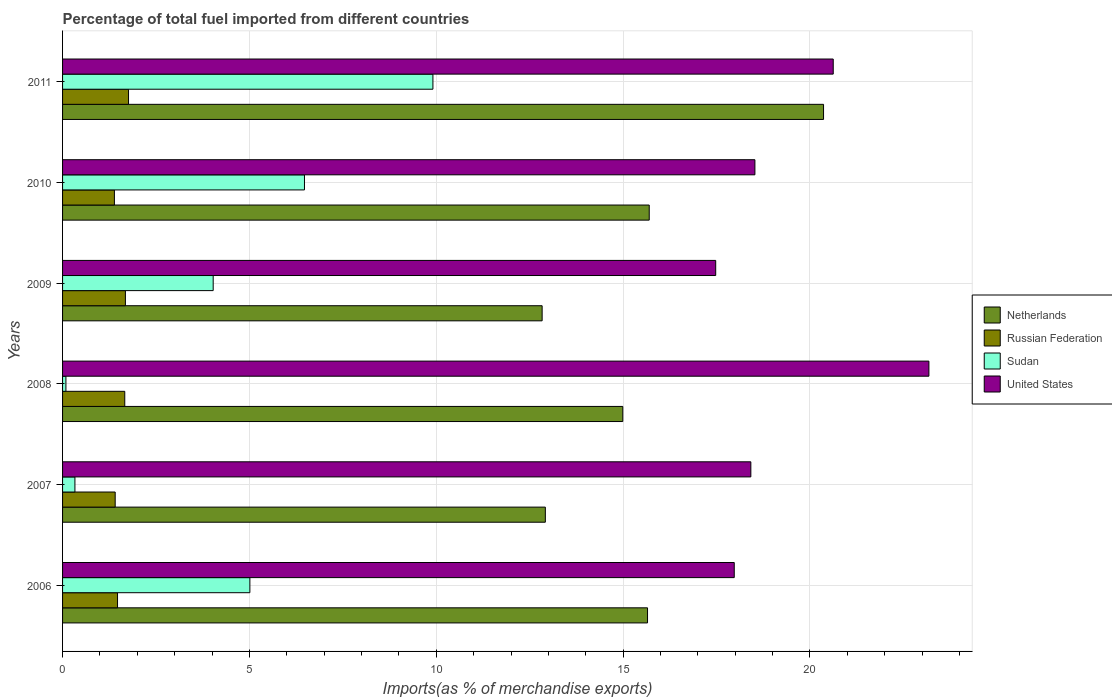How many groups of bars are there?
Make the answer very short. 6. Are the number of bars per tick equal to the number of legend labels?
Your response must be concise. Yes. How many bars are there on the 4th tick from the bottom?
Offer a very short reply. 4. What is the percentage of imports to different countries in Sudan in 2008?
Give a very brief answer. 0.09. Across all years, what is the maximum percentage of imports to different countries in Sudan?
Your response must be concise. 9.91. Across all years, what is the minimum percentage of imports to different countries in Netherlands?
Offer a terse response. 12.83. In which year was the percentage of imports to different countries in United States minimum?
Ensure brevity in your answer.  2009. What is the total percentage of imports to different countries in United States in the graph?
Your answer should be compact. 116.2. What is the difference between the percentage of imports to different countries in Sudan in 2008 and that in 2010?
Your answer should be compact. -6.38. What is the difference between the percentage of imports to different countries in Russian Federation in 2009 and the percentage of imports to different countries in United States in 2011?
Your response must be concise. -18.94. What is the average percentage of imports to different countries in United States per year?
Your answer should be very brief. 19.37. In the year 2011, what is the difference between the percentage of imports to different countries in Netherlands and percentage of imports to different countries in United States?
Give a very brief answer. -0.26. In how many years, is the percentage of imports to different countries in United States greater than 12 %?
Your answer should be very brief. 6. What is the ratio of the percentage of imports to different countries in Russian Federation in 2009 to that in 2010?
Your response must be concise. 1.21. Is the difference between the percentage of imports to different countries in Netherlands in 2008 and 2011 greater than the difference between the percentage of imports to different countries in United States in 2008 and 2011?
Your answer should be compact. No. What is the difference between the highest and the second highest percentage of imports to different countries in Netherlands?
Your response must be concise. 4.66. What is the difference between the highest and the lowest percentage of imports to different countries in Netherlands?
Your answer should be compact. 7.53. Is the sum of the percentage of imports to different countries in Netherlands in 2008 and 2011 greater than the maximum percentage of imports to different countries in Russian Federation across all years?
Give a very brief answer. Yes. What does the 3rd bar from the top in 2008 represents?
Provide a short and direct response. Russian Federation. What does the 2nd bar from the bottom in 2008 represents?
Your answer should be compact. Russian Federation. Is it the case that in every year, the sum of the percentage of imports to different countries in United States and percentage of imports to different countries in Sudan is greater than the percentage of imports to different countries in Russian Federation?
Ensure brevity in your answer.  Yes. Are the values on the major ticks of X-axis written in scientific E-notation?
Keep it short and to the point. No. Does the graph contain any zero values?
Provide a short and direct response. No. Where does the legend appear in the graph?
Your response must be concise. Center right. What is the title of the graph?
Offer a terse response. Percentage of total fuel imported from different countries. What is the label or title of the X-axis?
Keep it short and to the point. Imports(as % of merchandise exports). What is the Imports(as % of merchandise exports) of Netherlands in 2006?
Your answer should be very brief. 15.65. What is the Imports(as % of merchandise exports) in Russian Federation in 2006?
Offer a terse response. 1.47. What is the Imports(as % of merchandise exports) in Sudan in 2006?
Offer a terse response. 5.01. What is the Imports(as % of merchandise exports) in United States in 2006?
Give a very brief answer. 17.97. What is the Imports(as % of merchandise exports) in Netherlands in 2007?
Offer a very short reply. 12.92. What is the Imports(as % of merchandise exports) in Russian Federation in 2007?
Provide a succinct answer. 1.41. What is the Imports(as % of merchandise exports) in Sudan in 2007?
Give a very brief answer. 0.33. What is the Imports(as % of merchandise exports) of United States in 2007?
Make the answer very short. 18.42. What is the Imports(as % of merchandise exports) in Netherlands in 2008?
Make the answer very short. 14.99. What is the Imports(as % of merchandise exports) of Russian Federation in 2008?
Provide a succinct answer. 1.66. What is the Imports(as % of merchandise exports) in Sudan in 2008?
Offer a terse response. 0.09. What is the Imports(as % of merchandise exports) of United States in 2008?
Your answer should be very brief. 23.18. What is the Imports(as % of merchandise exports) in Netherlands in 2009?
Offer a very short reply. 12.83. What is the Imports(as % of merchandise exports) in Russian Federation in 2009?
Your answer should be very brief. 1.68. What is the Imports(as % of merchandise exports) in Sudan in 2009?
Provide a short and direct response. 4.03. What is the Imports(as % of merchandise exports) of United States in 2009?
Your answer should be very brief. 17.48. What is the Imports(as % of merchandise exports) in Netherlands in 2010?
Give a very brief answer. 15.7. What is the Imports(as % of merchandise exports) in Russian Federation in 2010?
Give a very brief answer. 1.39. What is the Imports(as % of merchandise exports) of Sudan in 2010?
Offer a terse response. 6.47. What is the Imports(as % of merchandise exports) in United States in 2010?
Your answer should be very brief. 18.53. What is the Imports(as % of merchandise exports) in Netherlands in 2011?
Your response must be concise. 20.36. What is the Imports(as % of merchandise exports) of Russian Federation in 2011?
Offer a terse response. 1.77. What is the Imports(as % of merchandise exports) of Sudan in 2011?
Keep it short and to the point. 9.91. What is the Imports(as % of merchandise exports) of United States in 2011?
Your response must be concise. 20.62. Across all years, what is the maximum Imports(as % of merchandise exports) of Netherlands?
Offer a very short reply. 20.36. Across all years, what is the maximum Imports(as % of merchandise exports) in Russian Federation?
Give a very brief answer. 1.77. Across all years, what is the maximum Imports(as % of merchandise exports) in Sudan?
Your answer should be compact. 9.91. Across all years, what is the maximum Imports(as % of merchandise exports) of United States?
Provide a succinct answer. 23.18. Across all years, what is the minimum Imports(as % of merchandise exports) of Netherlands?
Ensure brevity in your answer.  12.83. Across all years, what is the minimum Imports(as % of merchandise exports) of Russian Federation?
Offer a very short reply. 1.39. Across all years, what is the minimum Imports(as % of merchandise exports) of Sudan?
Keep it short and to the point. 0.09. Across all years, what is the minimum Imports(as % of merchandise exports) of United States?
Offer a terse response. 17.48. What is the total Imports(as % of merchandise exports) in Netherlands in the graph?
Keep it short and to the point. 92.46. What is the total Imports(as % of merchandise exports) of Russian Federation in the graph?
Your answer should be compact. 9.38. What is the total Imports(as % of merchandise exports) in Sudan in the graph?
Provide a short and direct response. 25.85. What is the total Imports(as % of merchandise exports) in United States in the graph?
Your answer should be very brief. 116.2. What is the difference between the Imports(as % of merchandise exports) in Netherlands in 2006 and that in 2007?
Your response must be concise. 2.73. What is the difference between the Imports(as % of merchandise exports) in Russian Federation in 2006 and that in 2007?
Make the answer very short. 0.06. What is the difference between the Imports(as % of merchandise exports) of Sudan in 2006 and that in 2007?
Your answer should be compact. 4.68. What is the difference between the Imports(as % of merchandise exports) of United States in 2006 and that in 2007?
Offer a terse response. -0.44. What is the difference between the Imports(as % of merchandise exports) in Netherlands in 2006 and that in 2008?
Give a very brief answer. 0.66. What is the difference between the Imports(as % of merchandise exports) of Russian Federation in 2006 and that in 2008?
Give a very brief answer. -0.19. What is the difference between the Imports(as % of merchandise exports) of Sudan in 2006 and that in 2008?
Give a very brief answer. 4.92. What is the difference between the Imports(as % of merchandise exports) of United States in 2006 and that in 2008?
Ensure brevity in your answer.  -5.21. What is the difference between the Imports(as % of merchandise exports) of Netherlands in 2006 and that in 2009?
Provide a short and direct response. 2.82. What is the difference between the Imports(as % of merchandise exports) in Russian Federation in 2006 and that in 2009?
Give a very brief answer. -0.21. What is the difference between the Imports(as % of merchandise exports) of Sudan in 2006 and that in 2009?
Give a very brief answer. 0.98. What is the difference between the Imports(as % of merchandise exports) in United States in 2006 and that in 2009?
Offer a very short reply. 0.5. What is the difference between the Imports(as % of merchandise exports) in Netherlands in 2006 and that in 2010?
Keep it short and to the point. -0.05. What is the difference between the Imports(as % of merchandise exports) of Russian Federation in 2006 and that in 2010?
Offer a terse response. 0.08. What is the difference between the Imports(as % of merchandise exports) in Sudan in 2006 and that in 2010?
Offer a terse response. -1.46. What is the difference between the Imports(as % of merchandise exports) of United States in 2006 and that in 2010?
Your answer should be very brief. -0.55. What is the difference between the Imports(as % of merchandise exports) in Netherlands in 2006 and that in 2011?
Provide a succinct answer. -4.71. What is the difference between the Imports(as % of merchandise exports) of Russian Federation in 2006 and that in 2011?
Provide a succinct answer. -0.29. What is the difference between the Imports(as % of merchandise exports) of Sudan in 2006 and that in 2011?
Offer a very short reply. -4.9. What is the difference between the Imports(as % of merchandise exports) of United States in 2006 and that in 2011?
Offer a terse response. -2.65. What is the difference between the Imports(as % of merchandise exports) in Netherlands in 2007 and that in 2008?
Your answer should be very brief. -2.07. What is the difference between the Imports(as % of merchandise exports) of Russian Federation in 2007 and that in 2008?
Give a very brief answer. -0.26. What is the difference between the Imports(as % of merchandise exports) of Sudan in 2007 and that in 2008?
Your response must be concise. 0.24. What is the difference between the Imports(as % of merchandise exports) of United States in 2007 and that in 2008?
Ensure brevity in your answer.  -4.76. What is the difference between the Imports(as % of merchandise exports) in Netherlands in 2007 and that in 2009?
Provide a short and direct response. 0.09. What is the difference between the Imports(as % of merchandise exports) of Russian Federation in 2007 and that in 2009?
Give a very brief answer. -0.27. What is the difference between the Imports(as % of merchandise exports) in Sudan in 2007 and that in 2009?
Offer a very short reply. -3.7. What is the difference between the Imports(as % of merchandise exports) of United States in 2007 and that in 2009?
Offer a terse response. 0.94. What is the difference between the Imports(as % of merchandise exports) in Netherlands in 2007 and that in 2010?
Offer a terse response. -2.78. What is the difference between the Imports(as % of merchandise exports) of Russian Federation in 2007 and that in 2010?
Provide a short and direct response. 0.02. What is the difference between the Imports(as % of merchandise exports) of Sudan in 2007 and that in 2010?
Make the answer very short. -6.14. What is the difference between the Imports(as % of merchandise exports) in United States in 2007 and that in 2010?
Keep it short and to the point. -0.11. What is the difference between the Imports(as % of merchandise exports) of Netherlands in 2007 and that in 2011?
Offer a very short reply. -7.44. What is the difference between the Imports(as % of merchandise exports) of Russian Federation in 2007 and that in 2011?
Provide a short and direct response. -0.36. What is the difference between the Imports(as % of merchandise exports) in Sudan in 2007 and that in 2011?
Provide a short and direct response. -9.58. What is the difference between the Imports(as % of merchandise exports) of United States in 2007 and that in 2011?
Ensure brevity in your answer.  -2.2. What is the difference between the Imports(as % of merchandise exports) in Netherlands in 2008 and that in 2009?
Your answer should be very brief. 2.16. What is the difference between the Imports(as % of merchandise exports) of Russian Federation in 2008 and that in 2009?
Offer a very short reply. -0.02. What is the difference between the Imports(as % of merchandise exports) in Sudan in 2008 and that in 2009?
Your answer should be very brief. -3.94. What is the difference between the Imports(as % of merchandise exports) in United States in 2008 and that in 2009?
Your answer should be compact. 5.71. What is the difference between the Imports(as % of merchandise exports) in Netherlands in 2008 and that in 2010?
Provide a short and direct response. -0.71. What is the difference between the Imports(as % of merchandise exports) of Russian Federation in 2008 and that in 2010?
Make the answer very short. 0.28. What is the difference between the Imports(as % of merchandise exports) in Sudan in 2008 and that in 2010?
Your answer should be compact. -6.38. What is the difference between the Imports(as % of merchandise exports) in United States in 2008 and that in 2010?
Ensure brevity in your answer.  4.66. What is the difference between the Imports(as % of merchandise exports) in Netherlands in 2008 and that in 2011?
Ensure brevity in your answer.  -5.37. What is the difference between the Imports(as % of merchandise exports) in Russian Federation in 2008 and that in 2011?
Your response must be concise. -0.1. What is the difference between the Imports(as % of merchandise exports) in Sudan in 2008 and that in 2011?
Give a very brief answer. -9.82. What is the difference between the Imports(as % of merchandise exports) in United States in 2008 and that in 2011?
Ensure brevity in your answer.  2.56. What is the difference between the Imports(as % of merchandise exports) of Netherlands in 2009 and that in 2010?
Offer a very short reply. -2.87. What is the difference between the Imports(as % of merchandise exports) of Russian Federation in 2009 and that in 2010?
Offer a very short reply. 0.29. What is the difference between the Imports(as % of merchandise exports) in Sudan in 2009 and that in 2010?
Ensure brevity in your answer.  -2.44. What is the difference between the Imports(as % of merchandise exports) of United States in 2009 and that in 2010?
Ensure brevity in your answer.  -1.05. What is the difference between the Imports(as % of merchandise exports) in Netherlands in 2009 and that in 2011?
Your answer should be compact. -7.53. What is the difference between the Imports(as % of merchandise exports) in Russian Federation in 2009 and that in 2011?
Give a very brief answer. -0.08. What is the difference between the Imports(as % of merchandise exports) of Sudan in 2009 and that in 2011?
Give a very brief answer. -5.88. What is the difference between the Imports(as % of merchandise exports) in United States in 2009 and that in 2011?
Offer a very short reply. -3.14. What is the difference between the Imports(as % of merchandise exports) in Netherlands in 2010 and that in 2011?
Ensure brevity in your answer.  -4.66. What is the difference between the Imports(as % of merchandise exports) of Russian Federation in 2010 and that in 2011?
Keep it short and to the point. -0.38. What is the difference between the Imports(as % of merchandise exports) in Sudan in 2010 and that in 2011?
Offer a very short reply. -3.44. What is the difference between the Imports(as % of merchandise exports) of United States in 2010 and that in 2011?
Offer a terse response. -2.1. What is the difference between the Imports(as % of merchandise exports) of Netherlands in 2006 and the Imports(as % of merchandise exports) of Russian Federation in 2007?
Your answer should be very brief. 14.25. What is the difference between the Imports(as % of merchandise exports) in Netherlands in 2006 and the Imports(as % of merchandise exports) in Sudan in 2007?
Make the answer very short. 15.32. What is the difference between the Imports(as % of merchandise exports) of Netherlands in 2006 and the Imports(as % of merchandise exports) of United States in 2007?
Your answer should be compact. -2.76. What is the difference between the Imports(as % of merchandise exports) in Russian Federation in 2006 and the Imports(as % of merchandise exports) in Sudan in 2007?
Your answer should be very brief. 1.14. What is the difference between the Imports(as % of merchandise exports) of Russian Federation in 2006 and the Imports(as % of merchandise exports) of United States in 2007?
Your answer should be very brief. -16.95. What is the difference between the Imports(as % of merchandise exports) of Sudan in 2006 and the Imports(as % of merchandise exports) of United States in 2007?
Your response must be concise. -13.41. What is the difference between the Imports(as % of merchandise exports) in Netherlands in 2006 and the Imports(as % of merchandise exports) in Russian Federation in 2008?
Your answer should be compact. 13.99. What is the difference between the Imports(as % of merchandise exports) of Netherlands in 2006 and the Imports(as % of merchandise exports) of Sudan in 2008?
Your answer should be compact. 15.56. What is the difference between the Imports(as % of merchandise exports) of Netherlands in 2006 and the Imports(as % of merchandise exports) of United States in 2008?
Offer a very short reply. -7.53. What is the difference between the Imports(as % of merchandise exports) of Russian Federation in 2006 and the Imports(as % of merchandise exports) of Sudan in 2008?
Provide a succinct answer. 1.38. What is the difference between the Imports(as % of merchandise exports) in Russian Federation in 2006 and the Imports(as % of merchandise exports) in United States in 2008?
Provide a succinct answer. -21.71. What is the difference between the Imports(as % of merchandise exports) in Sudan in 2006 and the Imports(as % of merchandise exports) in United States in 2008?
Offer a terse response. -18.17. What is the difference between the Imports(as % of merchandise exports) of Netherlands in 2006 and the Imports(as % of merchandise exports) of Russian Federation in 2009?
Your response must be concise. 13.97. What is the difference between the Imports(as % of merchandise exports) in Netherlands in 2006 and the Imports(as % of merchandise exports) in Sudan in 2009?
Offer a very short reply. 11.62. What is the difference between the Imports(as % of merchandise exports) in Netherlands in 2006 and the Imports(as % of merchandise exports) in United States in 2009?
Offer a very short reply. -1.82. What is the difference between the Imports(as % of merchandise exports) of Russian Federation in 2006 and the Imports(as % of merchandise exports) of Sudan in 2009?
Offer a terse response. -2.56. What is the difference between the Imports(as % of merchandise exports) in Russian Federation in 2006 and the Imports(as % of merchandise exports) in United States in 2009?
Keep it short and to the point. -16.01. What is the difference between the Imports(as % of merchandise exports) of Sudan in 2006 and the Imports(as % of merchandise exports) of United States in 2009?
Make the answer very short. -12.47. What is the difference between the Imports(as % of merchandise exports) of Netherlands in 2006 and the Imports(as % of merchandise exports) of Russian Federation in 2010?
Keep it short and to the point. 14.27. What is the difference between the Imports(as % of merchandise exports) in Netherlands in 2006 and the Imports(as % of merchandise exports) in Sudan in 2010?
Your response must be concise. 9.18. What is the difference between the Imports(as % of merchandise exports) in Netherlands in 2006 and the Imports(as % of merchandise exports) in United States in 2010?
Offer a very short reply. -2.87. What is the difference between the Imports(as % of merchandise exports) in Russian Federation in 2006 and the Imports(as % of merchandise exports) in Sudan in 2010?
Offer a very short reply. -5. What is the difference between the Imports(as % of merchandise exports) of Russian Federation in 2006 and the Imports(as % of merchandise exports) of United States in 2010?
Keep it short and to the point. -17.06. What is the difference between the Imports(as % of merchandise exports) in Sudan in 2006 and the Imports(as % of merchandise exports) in United States in 2010?
Your answer should be compact. -13.51. What is the difference between the Imports(as % of merchandise exports) of Netherlands in 2006 and the Imports(as % of merchandise exports) of Russian Federation in 2011?
Provide a succinct answer. 13.89. What is the difference between the Imports(as % of merchandise exports) of Netherlands in 2006 and the Imports(as % of merchandise exports) of Sudan in 2011?
Your response must be concise. 5.74. What is the difference between the Imports(as % of merchandise exports) in Netherlands in 2006 and the Imports(as % of merchandise exports) in United States in 2011?
Make the answer very short. -4.97. What is the difference between the Imports(as % of merchandise exports) in Russian Federation in 2006 and the Imports(as % of merchandise exports) in Sudan in 2011?
Provide a succinct answer. -8.44. What is the difference between the Imports(as % of merchandise exports) of Russian Federation in 2006 and the Imports(as % of merchandise exports) of United States in 2011?
Give a very brief answer. -19.15. What is the difference between the Imports(as % of merchandise exports) in Sudan in 2006 and the Imports(as % of merchandise exports) in United States in 2011?
Give a very brief answer. -15.61. What is the difference between the Imports(as % of merchandise exports) of Netherlands in 2007 and the Imports(as % of merchandise exports) of Russian Federation in 2008?
Give a very brief answer. 11.25. What is the difference between the Imports(as % of merchandise exports) in Netherlands in 2007 and the Imports(as % of merchandise exports) in Sudan in 2008?
Ensure brevity in your answer.  12.83. What is the difference between the Imports(as % of merchandise exports) of Netherlands in 2007 and the Imports(as % of merchandise exports) of United States in 2008?
Provide a succinct answer. -10.26. What is the difference between the Imports(as % of merchandise exports) of Russian Federation in 2007 and the Imports(as % of merchandise exports) of Sudan in 2008?
Offer a terse response. 1.32. What is the difference between the Imports(as % of merchandise exports) in Russian Federation in 2007 and the Imports(as % of merchandise exports) in United States in 2008?
Your answer should be compact. -21.77. What is the difference between the Imports(as % of merchandise exports) of Sudan in 2007 and the Imports(as % of merchandise exports) of United States in 2008?
Make the answer very short. -22.85. What is the difference between the Imports(as % of merchandise exports) of Netherlands in 2007 and the Imports(as % of merchandise exports) of Russian Federation in 2009?
Offer a very short reply. 11.24. What is the difference between the Imports(as % of merchandise exports) of Netherlands in 2007 and the Imports(as % of merchandise exports) of Sudan in 2009?
Keep it short and to the point. 8.89. What is the difference between the Imports(as % of merchandise exports) of Netherlands in 2007 and the Imports(as % of merchandise exports) of United States in 2009?
Provide a succinct answer. -4.56. What is the difference between the Imports(as % of merchandise exports) of Russian Federation in 2007 and the Imports(as % of merchandise exports) of Sudan in 2009?
Make the answer very short. -2.62. What is the difference between the Imports(as % of merchandise exports) of Russian Federation in 2007 and the Imports(as % of merchandise exports) of United States in 2009?
Give a very brief answer. -16.07. What is the difference between the Imports(as % of merchandise exports) in Sudan in 2007 and the Imports(as % of merchandise exports) in United States in 2009?
Your response must be concise. -17.15. What is the difference between the Imports(as % of merchandise exports) of Netherlands in 2007 and the Imports(as % of merchandise exports) of Russian Federation in 2010?
Provide a succinct answer. 11.53. What is the difference between the Imports(as % of merchandise exports) of Netherlands in 2007 and the Imports(as % of merchandise exports) of Sudan in 2010?
Your answer should be compact. 6.45. What is the difference between the Imports(as % of merchandise exports) of Netherlands in 2007 and the Imports(as % of merchandise exports) of United States in 2010?
Your answer should be compact. -5.61. What is the difference between the Imports(as % of merchandise exports) of Russian Federation in 2007 and the Imports(as % of merchandise exports) of Sudan in 2010?
Your answer should be compact. -5.07. What is the difference between the Imports(as % of merchandise exports) in Russian Federation in 2007 and the Imports(as % of merchandise exports) in United States in 2010?
Offer a terse response. -17.12. What is the difference between the Imports(as % of merchandise exports) of Sudan in 2007 and the Imports(as % of merchandise exports) of United States in 2010?
Your response must be concise. -18.2. What is the difference between the Imports(as % of merchandise exports) in Netherlands in 2007 and the Imports(as % of merchandise exports) in Russian Federation in 2011?
Keep it short and to the point. 11.15. What is the difference between the Imports(as % of merchandise exports) in Netherlands in 2007 and the Imports(as % of merchandise exports) in Sudan in 2011?
Ensure brevity in your answer.  3.01. What is the difference between the Imports(as % of merchandise exports) of Netherlands in 2007 and the Imports(as % of merchandise exports) of United States in 2011?
Keep it short and to the point. -7.7. What is the difference between the Imports(as % of merchandise exports) in Russian Federation in 2007 and the Imports(as % of merchandise exports) in Sudan in 2011?
Offer a very short reply. -8.5. What is the difference between the Imports(as % of merchandise exports) of Russian Federation in 2007 and the Imports(as % of merchandise exports) of United States in 2011?
Provide a succinct answer. -19.21. What is the difference between the Imports(as % of merchandise exports) of Sudan in 2007 and the Imports(as % of merchandise exports) of United States in 2011?
Your answer should be very brief. -20.29. What is the difference between the Imports(as % of merchandise exports) of Netherlands in 2008 and the Imports(as % of merchandise exports) of Russian Federation in 2009?
Provide a succinct answer. 13.31. What is the difference between the Imports(as % of merchandise exports) in Netherlands in 2008 and the Imports(as % of merchandise exports) in Sudan in 2009?
Your response must be concise. 10.96. What is the difference between the Imports(as % of merchandise exports) of Netherlands in 2008 and the Imports(as % of merchandise exports) of United States in 2009?
Offer a very short reply. -2.49. What is the difference between the Imports(as % of merchandise exports) of Russian Federation in 2008 and the Imports(as % of merchandise exports) of Sudan in 2009?
Your answer should be compact. -2.37. What is the difference between the Imports(as % of merchandise exports) of Russian Federation in 2008 and the Imports(as % of merchandise exports) of United States in 2009?
Provide a short and direct response. -15.81. What is the difference between the Imports(as % of merchandise exports) in Sudan in 2008 and the Imports(as % of merchandise exports) in United States in 2009?
Keep it short and to the point. -17.39. What is the difference between the Imports(as % of merchandise exports) in Netherlands in 2008 and the Imports(as % of merchandise exports) in Russian Federation in 2010?
Give a very brief answer. 13.6. What is the difference between the Imports(as % of merchandise exports) of Netherlands in 2008 and the Imports(as % of merchandise exports) of Sudan in 2010?
Offer a terse response. 8.52. What is the difference between the Imports(as % of merchandise exports) of Netherlands in 2008 and the Imports(as % of merchandise exports) of United States in 2010?
Give a very brief answer. -3.53. What is the difference between the Imports(as % of merchandise exports) in Russian Federation in 2008 and the Imports(as % of merchandise exports) in Sudan in 2010?
Offer a very short reply. -4.81. What is the difference between the Imports(as % of merchandise exports) in Russian Federation in 2008 and the Imports(as % of merchandise exports) in United States in 2010?
Ensure brevity in your answer.  -16.86. What is the difference between the Imports(as % of merchandise exports) of Sudan in 2008 and the Imports(as % of merchandise exports) of United States in 2010?
Make the answer very short. -18.44. What is the difference between the Imports(as % of merchandise exports) in Netherlands in 2008 and the Imports(as % of merchandise exports) in Russian Federation in 2011?
Offer a terse response. 13.23. What is the difference between the Imports(as % of merchandise exports) of Netherlands in 2008 and the Imports(as % of merchandise exports) of Sudan in 2011?
Offer a very short reply. 5.08. What is the difference between the Imports(as % of merchandise exports) in Netherlands in 2008 and the Imports(as % of merchandise exports) in United States in 2011?
Make the answer very short. -5.63. What is the difference between the Imports(as % of merchandise exports) of Russian Federation in 2008 and the Imports(as % of merchandise exports) of Sudan in 2011?
Make the answer very short. -8.25. What is the difference between the Imports(as % of merchandise exports) in Russian Federation in 2008 and the Imports(as % of merchandise exports) in United States in 2011?
Ensure brevity in your answer.  -18.96. What is the difference between the Imports(as % of merchandise exports) in Sudan in 2008 and the Imports(as % of merchandise exports) in United States in 2011?
Your response must be concise. -20.53. What is the difference between the Imports(as % of merchandise exports) in Netherlands in 2009 and the Imports(as % of merchandise exports) in Russian Federation in 2010?
Offer a very short reply. 11.45. What is the difference between the Imports(as % of merchandise exports) of Netherlands in 2009 and the Imports(as % of merchandise exports) of Sudan in 2010?
Provide a short and direct response. 6.36. What is the difference between the Imports(as % of merchandise exports) of Netherlands in 2009 and the Imports(as % of merchandise exports) of United States in 2010?
Keep it short and to the point. -5.69. What is the difference between the Imports(as % of merchandise exports) of Russian Federation in 2009 and the Imports(as % of merchandise exports) of Sudan in 2010?
Your answer should be very brief. -4.79. What is the difference between the Imports(as % of merchandise exports) in Russian Federation in 2009 and the Imports(as % of merchandise exports) in United States in 2010?
Make the answer very short. -16.84. What is the difference between the Imports(as % of merchandise exports) of Sudan in 2009 and the Imports(as % of merchandise exports) of United States in 2010?
Offer a very short reply. -14.5. What is the difference between the Imports(as % of merchandise exports) of Netherlands in 2009 and the Imports(as % of merchandise exports) of Russian Federation in 2011?
Make the answer very short. 11.07. What is the difference between the Imports(as % of merchandise exports) of Netherlands in 2009 and the Imports(as % of merchandise exports) of Sudan in 2011?
Your answer should be very brief. 2.92. What is the difference between the Imports(as % of merchandise exports) in Netherlands in 2009 and the Imports(as % of merchandise exports) in United States in 2011?
Ensure brevity in your answer.  -7.79. What is the difference between the Imports(as % of merchandise exports) of Russian Federation in 2009 and the Imports(as % of merchandise exports) of Sudan in 2011?
Ensure brevity in your answer.  -8.23. What is the difference between the Imports(as % of merchandise exports) in Russian Federation in 2009 and the Imports(as % of merchandise exports) in United States in 2011?
Give a very brief answer. -18.94. What is the difference between the Imports(as % of merchandise exports) in Sudan in 2009 and the Imports(as % of merchandise exports) in United States in 2011?
Provide a short and direct response. -16.59. What is the difference between the Imports(as % of merchandise exports) of Netherlands in 2010 and the Imports(as % of merchandise exports) of Russian Federation in 2011?
Offer a terse response. 13.93. What is the difference between the Imports(as % of merchandise exports) in Netherlands in 2010 and the Imports(as % of merchandise exports) in Sudan in 2011?
Give a very brief answer. 5.79. What is the difference between the Imports(as % of merchandise exports) of Netherlands in 2010 and the Imports(as % of merchandise exports) of United States in 2011?
Keep it short and to the point. -4.92. What is the difference between the Imports(as % of merchandise exports) in Russian Federation in 2010 and the Imports(as % of merchandise exports) in Sudan in 2011?
Provide a short and direct response. -8.52. What is the difference between the Imports(as % of merchandise exports) of Russian Federation in 2010 and the Imports(as % of merchandise exports) of United States in 2011?
Offer a very short reply. -19.23. What is the difference between the Imports(as % of merchandise exports) of Sudan in 2010 and the Imports(as % of merchandise exports) of United States in 2011?
Give a very brief answer. -14.15. What is the average Imports(as % of merchandise exports) of Netherlands per year?
Provide a succinct answer. 15.41. What is the average Imports(as % of merchandise exports) of Russian Federation per year?
Provide a short and direct response. 1.56. What is the average Imports(as % of merchandise exports) in Sudan per year?
Offer a terse response. 4.31. What is the average Imports(as % of merchandise exports) in United States per year?
Your response must be concise. 19.37. In the year 2006, what is the difference between the Imports(as % of merchandise exports) of Netherlands and Imports(as % of merchandise exports) of Russian Federation?
Offer a very short reply. 14.18. In the year 2006, what is the difference between the Imports(as % of merchandise exports) in Netherlands and Imports(as % of merchandise exports) in Sudan?
Offer a very short reply. 10.64. In the year 2006, what is the difference between the Imports(as % of merchandise exports) of Netherlands and Imports(as % of merchandise exports) of United States?
Make the answer very short. -2.32. In the year 2006, what is the difference between the Imports(as % of merchandise exports) of Russian Federation and Imports(as % of merchandise exports) of Sudan?
Keep it short and to the point. -3.54. In the year 2006, what is the difference between the Imports(as % of merchandise exports) in Russian Federation and Imports(as % of merchandise exports) in United States?
Ensure brevity in your answer.  -16.5. In the year 2006, what is the difference between the Imports(as % of merchandise exports) in Sudan and Imports(as % of merchandise exports) in United States?
Provide a succinct answer. -12.96. In the year 2007, what is the difference between the Imports(as % of merchandise exports) in Netherlands and Imports(as % of merchandise exports) in Russian Federation?
Keep it short and to the point. 11.51. In the year 2007, what is the difference between the Imports(as % of merchandise exports) of Netherlands and Imports(as % of merchandise exports) of Sudan?
Offer a terse response. 12.59. In the year 2007, what is the difference between the Imports(as % of merchandise exports) in Netherlands and Imports(as % of merchandise exports) in United States?
Give a very brief answer. -5.5. In the year 2007, what is the difference between the Imports(as % of merchandise exports) in Russian Federation and Imports(as % of merchandise exports) in Sudan?
Ensure brevity in your answer.  1.08. In the year 2007, what is the difference between the Imports(as % of merchandise exports) in Russian Federation and Imports(as % of merchandise exports) in United States?
Make the answer very short. -17.01. In the year 2007, what is the difference between the Imports(as % of merchandise exports) of Sudan and Imports(as % of merchandise exports) of United States?
Keep it short and to the point. -18.09. In the year 2008, what is the difference between the Imports(as % of merchandise exports) in Netherlands and Imports(as % of merchandise exports) in Russian Federation?
Your answer should be very brief. 13.33. In the year 2008, what is the difference between the Imports(as % of merchandise exports) of Netherlands and Imports(as % of merchandise exports) of Sudan?
Your response must be concise. 14.9. In the year 2008, what is the difference between the Imports(as % of merchandise exports) of Netherlands and Imports(as % of merchandise exports) of United States?
Provide a succinct answer. -8.19. In the year 2008, what is the difference between the Imports(as % of merchandise exports) of Russian Federation and Imports(as % of merchandise exports) of Sudan?
Ensure brevity in your answer.  1.57. In the year 2008, what is the difference between the Imports(as % of merchandise exports) in Russian Federation and Imports(as % of merchandise exports) in United States?
Your answer should be compact. -21.52. In the year 2008, what is the difference between the Imports(as % of merchandise exports) of Sudan and Imports(as % of merchandise exports) of United States?
Make the answer very short. -23.09. In the year 2009, what is the difference between the Imports(as % of merchandise exports) of Netherlands and Imports(as % of merchandise exports) of Russian Federation?
Keep it short and to the point. 11.15. In the year 2009, what is the difference between the Imports(as % of merchandise exports) of Netherlands and Imports(as % of merchandise exports) of Sudan?
Offer a terse response. 8.8. In the year 2009, what is the difference between the Imports(as % of merchandise exports) in Netherlands and Imports(as % of merchandise exports) in United States?
Offer a terse response. -4.64. In the year 2009, what is the difference between the Imports(as % of merchandise exports) in Russian Federation and Imports(as % of merchandise exports) in Sudan?
Provide a short and direct response. -2.35. In the year 2009, what is the difference between the Imports(as % of merchandise exports) in Russian Federation and Imports(as % of merchandise exports) in United States?
Your response must be concise. -15.8. In the year 2009, what is the difference between the Imports(as % of merchandise exports) in Sudan and Imports(as % of merchandise exports) in United States?
Provide a short and direct response. -13.45. In the year 2010, what is the difference between the Imports(as % of merchandise exports) of Netherlands and Imports(as % of merchandise exports) of Russian Federation?
Your response must be concise. 14.31. In the year 2010, what is the difference between the Imports(as % of merchandise exports) in Netherlands and Imports(as % of merchandise exports) in Sudan?
Provide a succinct answer. 9.23. In the year 2010, what is the difference between the Imports(as % of merchandise exports) in Netherlands and Imports(as % of merchandise exports) in United States?
Your answer should be very brief. -2.83. In the year 2010, what is the difference between the Imports(as % of merchandise exports) of Russian Federation and Imports(as % of merchandise exports) of Sudan?
Provide a short and direct response. -5.09. In the year 2010, what is the difference between the Imports(as % of merchandise exports) of Russian Federation and Imports(as % of merchandise exports) of United States?
Ensure brevity in your answer.  -17.14. In the year 2010, what is the difference between the Imports(as % of merchandise exports) in Sudan and Imports(as % of merchandise exports) in United States?
Your answer should be very brief. -12.05. In the year 2011, what is the difference between the Imports(as % of merchandise exports) in Netherlands and Imports(as % of merchandise exports) in Russian Federation?
Your response must be concise. 18.6. In the year 2011, what is the difference between the Imports(as % of merchandise exports) in Netherlands and Imports(as % of merchandise exports) in Sudan?
Your response must be concise. 10.45. In the year 2011, what is the difference between the Imports(as % of merchandise exports) in Netherlands and Imports(as % of merchandise exports) in United States?
Ensure brevity in your answer.  -0.26. In the year 2011, what is the difference between the Imports(as % of merchandise exports) of Russian Federation and Imports(as % of merchandise exports) of Sudan?
Make the answer very short. -8.15. In the year 2011, what is the difference between the Imports(as % of merchandise exports) in Russian Federation and Imports(as % of merchandise exports) in United States?
Offer a very short reply. -18.86. In the year 2011, what is the difference between the Imports(as % of merchandise exports) of Sudan and Imports(as % of merchandise exports) of United States?
Your response must be concise. -10.71. What is the ratio of the Imports(as % of merchandise exports) in Netherlands in 2006 to that in 2007?
Provide a short and direct response. 1.21. What is the ratio of the Imports(as % of merchandise exports) of Russian Federation in 2006 to that in 2007?
Your response must be concise. 1.04. What is the ratio of the Imports(as % of merchandise exports) in Sudan in 2006 to that in 2007?
Offer a terse response. 15.15. What is the ratio of the Imports(as % of merchandise exports) of United States in 2006 to that in 2007?
Your response must be concise. 0.98. What is the ratio of the Imports(as % of merchandise exports) of Netherlands in 2006 to that in 2008?
Offer a terse response. 1.04. What is the ratio of the Imports(as % of merchandise exports) in Russian Federation in 2006 to that in 2008?
Your response must be concise. 0.88. What is the ratio of the Imports(as % of merchandise exports) in Sudan in 2006 to that in 2008?
Provide a short and direct response. 55.77. What is the ratio of the Imports(as % of merchandise exports) of United States in 2006 to that in 2008?
Your answer should be compact. 0.78. What is the ratio of the Imports(as % of merchandise exports) in Netherlands in 2006 to that in 2009?
Your response must be concise. 1.22. What is the ratio of the Imports(as % of merchandise exports) of Russian Federation in 2006 to that in 2009?
Make the answer very short. 0.87. What is the ratio of the Imports(as % of merchandise exports) in Sudan in 2006 to that in 2009?
Provide a short and direct response. 1.24. What is the ratio of the Imports(as % of merchandise exports) of United States in 2006 to that in 2009?
Offer a very short reply. 1.03. What is the ratio of the Imports(as % of merchandise exports) in Russian Federation in 2006 to that in 2010?
Provide a short and direct response. 1.06. What is the ratio of the Imports(as % of merchandise exports) of Sudan in 2006 to that in 2010?
Offer a very short reply. 0.77. What is the ratio of the Imports(as % of merchandise exports) of United States in 2006 to that in 2010?
Provide a succinct answer. 0.97. What is the ratio of the Imports(as % of merchandise exports) of Netherlands in 2006 to that in 2011?
Offer a terse response. 0.77. What is the ratio of the Imports(as % of merchandise exports) of Russian Federation in 2006 to that in 2011?
Provide a short and direct response. 0.83. What is the ratio of the Imports(as % of merchandise exports) in Sudan in 2006 to that in 2011?
Your answer should be compact. 0.51. What is the ratio of the Imports(as % of merchandise exports) in United States in 2006 to that in 2011?
Ensure brevity in your answer.  0.87. What is the ratio of the Imports(as % of merchandise exports) of Netherlands in 2007 to that in 2008?
Offer a very short reply. 0.86. What is the ratio of the Imports(as % of merchandise exports) of Russian Federation in 2007 to that in 2008?
Offer a terse response. 0.85. What is the ratio of the Imports(as % of merchandise exports) in Sudan in 2007 to that in 2008?
Your answer should be compact. 3.68. What is the ratio of the Imports(as % of merchandise exports) of United States in 2007 to that in 2008?
Your answer should be compact. 0.79. What is the ratio of the Imports(as % of merchandise exports) of Russian Federation in 2007 to that in 2009?
Provide a short and direct response. 0.84. What is the ratio of the Imports(as % of merchandise exports) of Sudan in 2007 to that in 2009?
Your response must be concise. 0.08. What is the ratio of the Imports(as % of merchandise exports) in United States in 2007 to that in 2009?
Offer a very short reply. 1.05. What is the ratio of the Imports(as % of merchandise exports) in Netherlands in 2007 to that in 2010?
Your answer should be very brief. 0.82. What is the ratio of the Imports(as % of merchandise exports) of Russian Federation in 2007 to that in 2010?
Provide a succinct answer. 1.01. What is the ratio of the Imports(as % of merchandise exports) of Sudan in 2007 to that in 2010?
Your response must be concise. 0.05. What is the ratio of the Imports(as % of merchandise exports) of Netherlands in 2007 to that in 2011?
Ensure brevity in your answer.  0.63. What is the ratio of the Imports(as % of merchandise exports) of Russian Federation in 2007 to that in 2011?
Provide a short and direct response. 0.8. What is the ratio of the Imports(as % of merchandise exports) of Sudan in 2007 to that in 2011?
Your answer should be compact. 0.03. What is the ratio of the Imports(as % of merchandise exports) of United States in 2007 to that in 2011?
Provide a succinct answer. 0.89. What is the ratio of the Imports(as % of merchandise exports) in Netherlands in 2008 to that in 2009?
Your answer should be very brief. 1.17. What is the ratio of the Imports(as % of merchandise exports) in Russian Federation in 2008 to that in 2009?
Offer a terse response. 0.99. What is the ratio of the Imports(as % of merchandise exports) of Sudan in 2008 to that in 2009?
Keep it short and to the point. 0.02. What is the ratio of the Imports(as % of merchandise exports) in United States in 2008 to that in 2009?
Offer a very short reply. 1.33. What is the ratio of the Imports(as % of merchandise exports) in Netherlands in 2008 to that in 2010?
Offer a terse response. 0.95. What is the ratio of the Imports(as % of merchandise exports) in Russian Federation in 2008 to that in 2010?
Provide a short and direct response. 1.2. What is the ratio of the Imports(as % of merchandise exports) of Sudan in 2008 to that in 2010?
Make the answer very short. 0.01. What is the ratio of the Imports(as % of merchandise exports) in United States in 2008 to that in 2010?
Make the answer very short. 1.25. What is the ratio of the Imports(as % of merchandise exports) of Netherlands in 2008 to that in 2011?
Ensure brevity in your answer.  0.74. What is the ratio of the Imports(as % of merchandise exports) of Russian Federation in 2008 to that in 2011?
Offer a terse response. 0.94. What is the ratio of the Imports(as % of merchandise exports) of Sudan in 2008 to that in 2011?
Your answer should be compact. 0.01. What is the ratio of the Imports(as % of merchandise exports) in United States in 2008 to that in 2011?
Your response must be concise. 1.12. What is the ratio of the Imports(as % of merchandise exports) in Netherlands in 2009 to that in 2010?
Give a very brief answer. 0.82. What is the ratio of the Imports(as % of merchandise exports) in Russian Federation in 2009 to that in 2010?
Make the answer very short. 1.21. What is the ratio of the Imports(as % of merchandise exports) of Sudan in 2009 to that in 2010?
Offer a very short reply. 0.62. What is the ratio of the Imports(as % of merchandise exports) of United States in 2009 to that in 2010?
Give a very brief answer. 0.94. What is the ratio of the Imports(as % of merchandise exports) of Netherlands in 2009 to that in 2011?
Provide a succinct answer. 0.63. What is the ratio of the Imports(as % of merchandise exports) of Russian Federation in 2009 to that in 2011?
Offer a very short reply. 0.95. What is the ratio of the Imports(as % of merchandise exports) in Sudan in 2009 to that in 2011?
Your answer should be compact. 0.41. What is the ratio of the Imports(as % of merchandise exports) in United States in 2009 to that in 2011?
Make the answer very short. 0.85. What is the ratio of the Imports(as % of merchandise exports) in Netherlands in 2010 to that in 2011?
Your answer should be very brief. 0.77. What is the ratio of the Imports(as % of merchandise exports) in Russian Federation in 2010 to that in 2011?
Offer a very short reply. 0.79. What is the ratio of the Imports(as % of merchandise exports) in Sudan in 2010 to that in 2011?
Ensure brevity in your answer.  0.65. What is the ratio of the Imports(as % of merchandise exports) of United States in 2010 to that in 2011?
Offer a terse response. 0.9. What is the difference between the highest and the second highest Imports(as % of merchandise exports) in Netherlands?
Make the answer very short. 4.66. What is the difference between the highest and the second highest Imports(as % of merchandise exports) in Russian Federation?
Keep it short and to the point. 0.08. What is the difference between the highest and the second highest Imports(as % of merchandise exports) of Sudan?
Your answer should be very brief. 3.44. What is the difference between the highest and the second highest Imports(as % of merchandise exports) of United States?
Ensure brevity in your answer.  2.56. What is the difference between the highest and the lowest Imports(as % of merchandise exports) in Netherlands?
Your answer should be compact. 7.53. What is the difference between the highest and the lowest Imports(as % of merchandise exports) in Russian Federation?
Give a very brief answer. 0.38. What is the difference between the highest and the lowest Imports(as % of merchandise exports) in Sudan?
Provide a succinct answer. 9.82. What is the difference between the highest and the lowest Imports(as % of merchandise exports) in United States?
Provide a short and direct response. 5.71. 